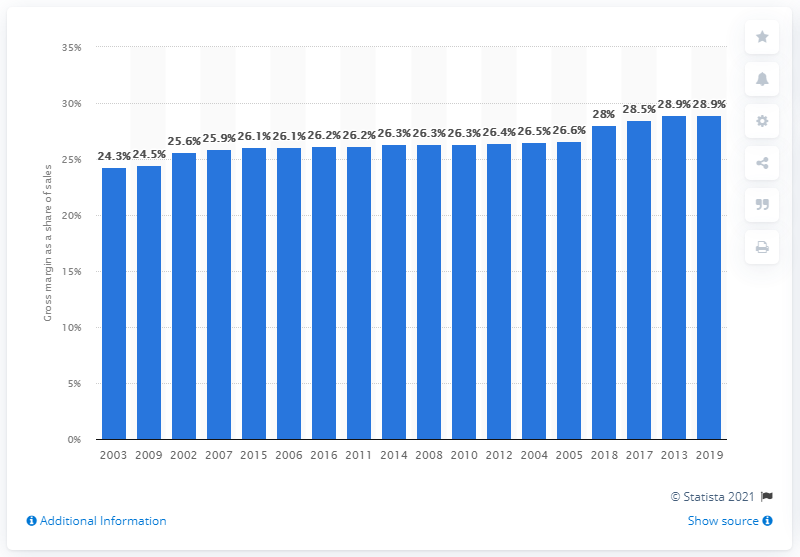Highlight a few significant elements in this photo. In 2020, the gross margin of U.S. merchant wholesalers of beer, wine, and distilled alcoholic beverages was 28.9%. 